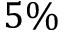Convert formula to latex. <formula><loc_0><loc_0><loc_500><loc_500>5 \%</formula> 